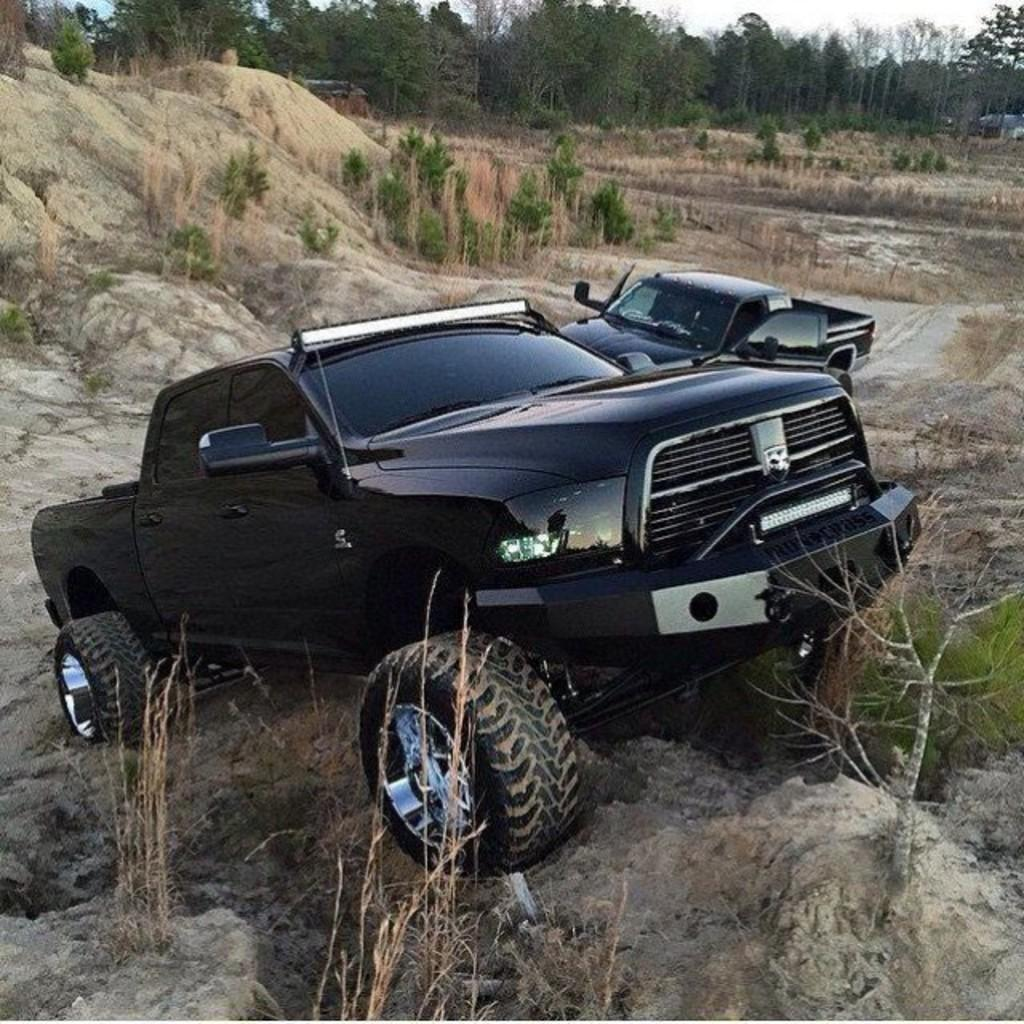What type of vehicles are present in the image? There are cars in the image. Where are the cars located? The cars are on a hill area. What can be seen in the background of the image? There are plants and trees in the background of the image. How many boys are riding on the plane in the image? There is no plane or boys present in the image. What type of writing instrument is being used by the quill in the image? There is no quill present in the image. 